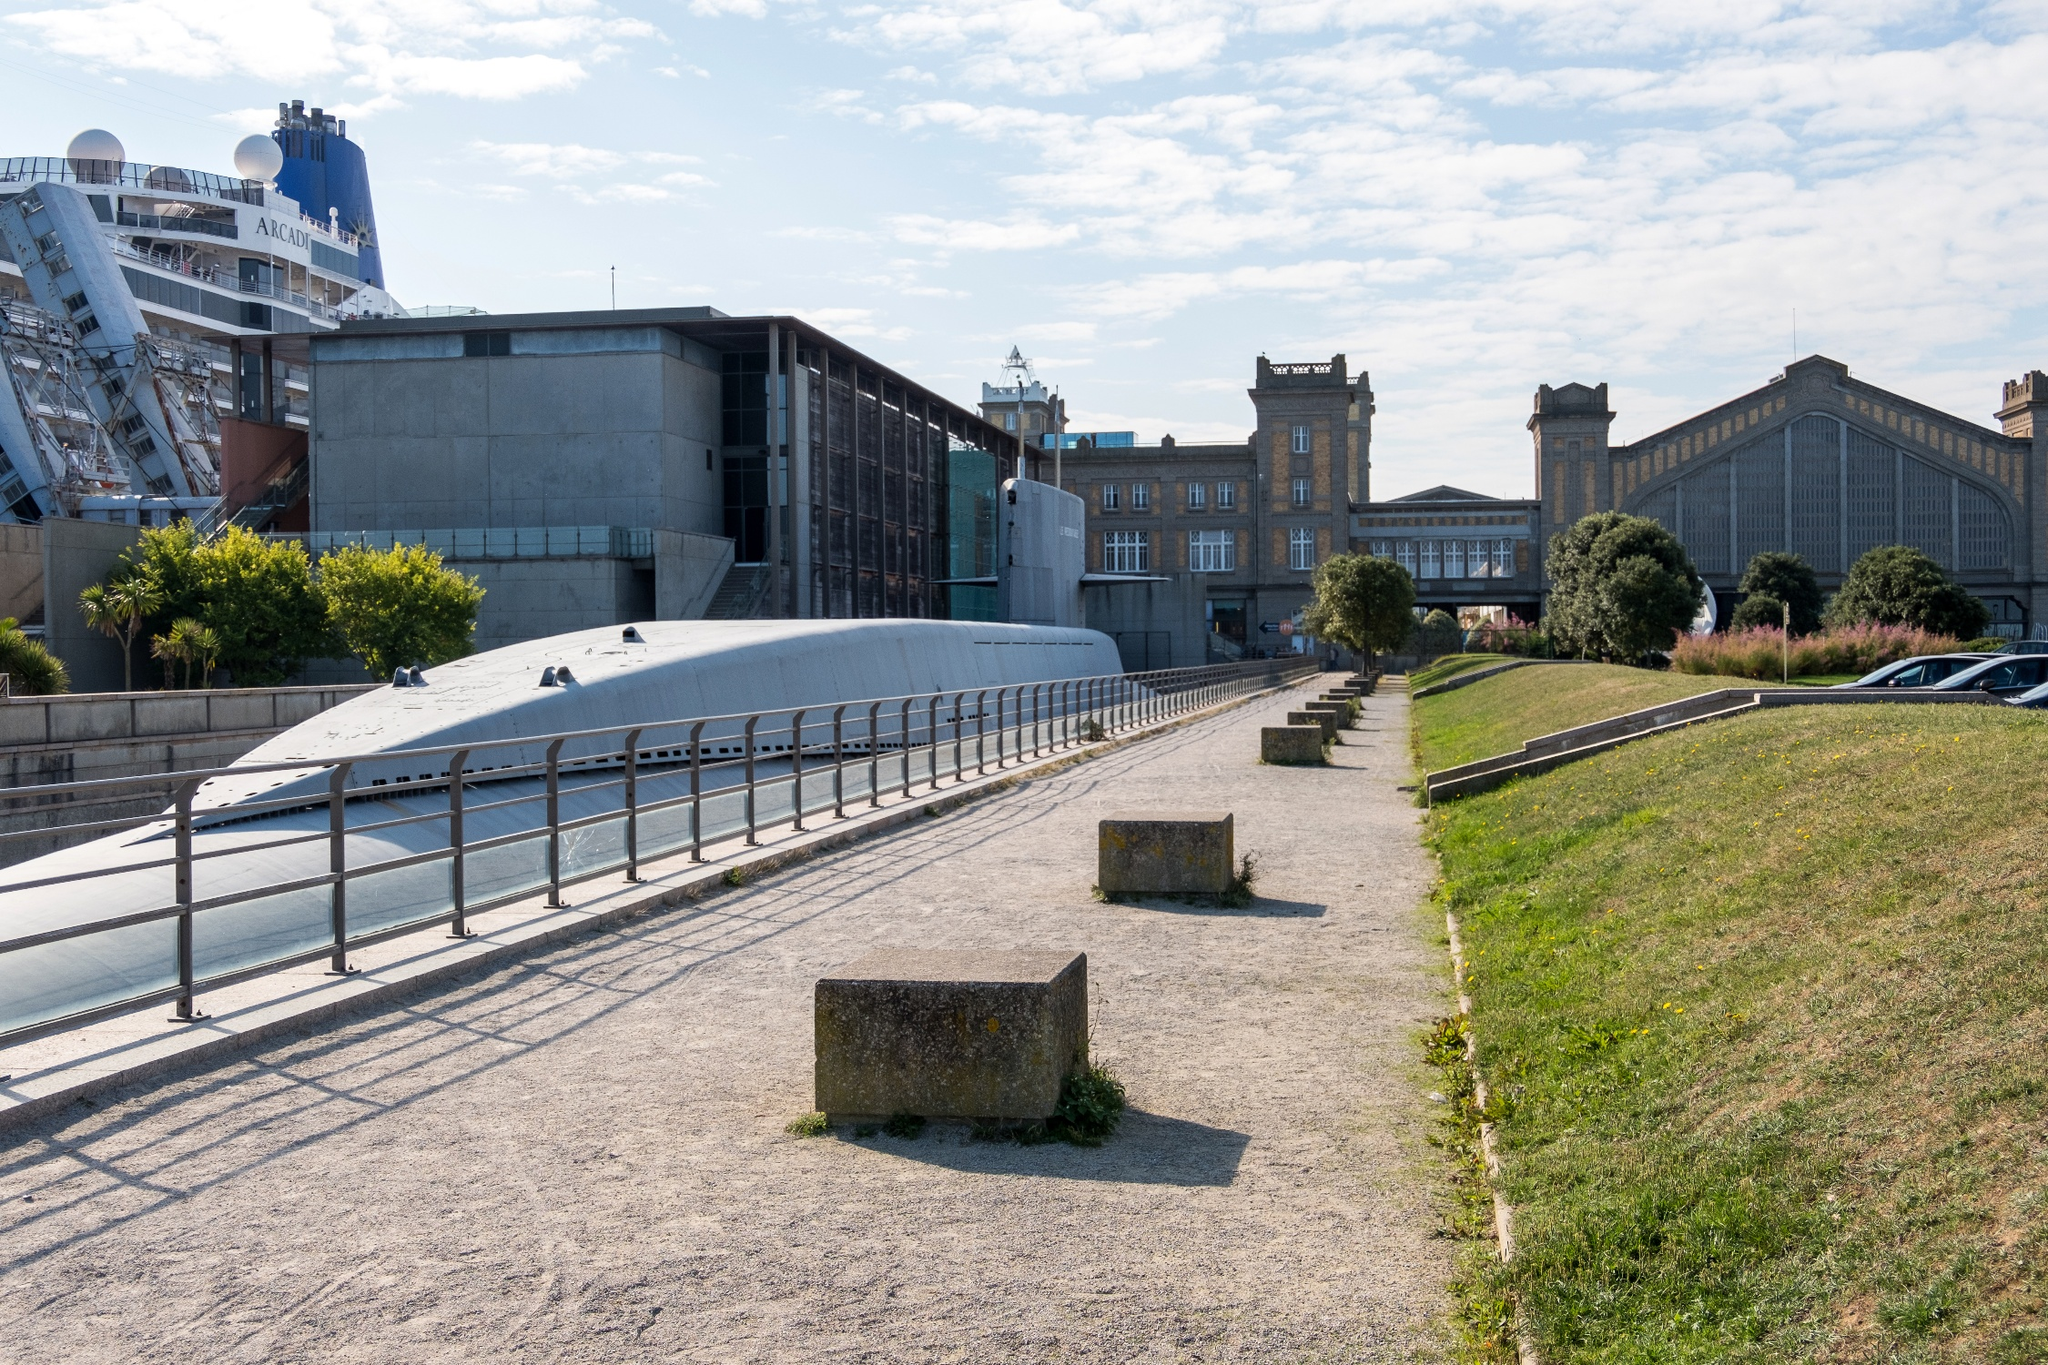Can you describe the architecture visible in the image? The architecture in the image presents a mix of modern and traditional styles. The traditional buildings in the background exude a sense of history, with masonry that hints at their long-standing presence in the city. In contrast, the modern structures near the foreground are characterized by their sleek lines and contemporary design, including extensive glass and concrete work. This juxtaposition marks Cherbourg-Octeville as a place where history and progress coexist seamlessly, painting a dynamic and compelling urban landscape. 